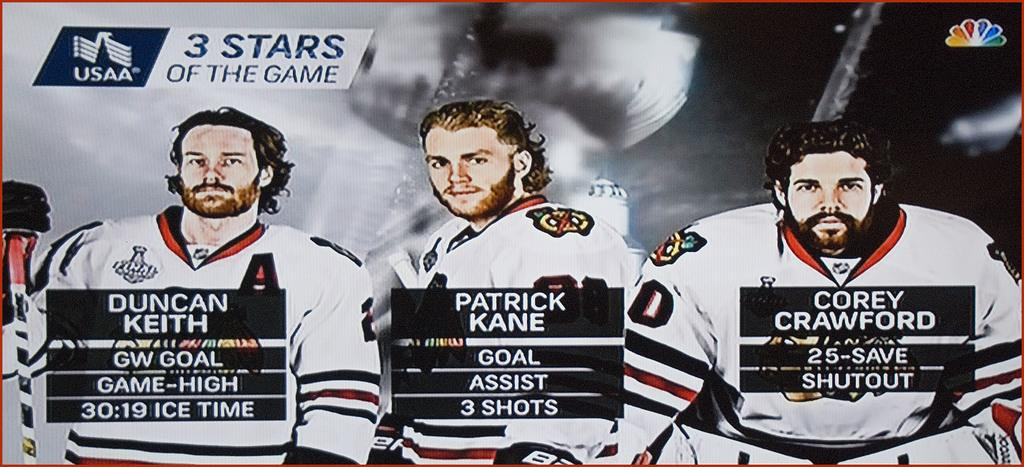<image>
Relay a brief, clear account of the picture shown. a Patrick Kane photo with other players as well 